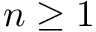Convert formula to latex. <formula><loc_0><loc_0><loc_500><loc_500>n \geq 1</formula> 